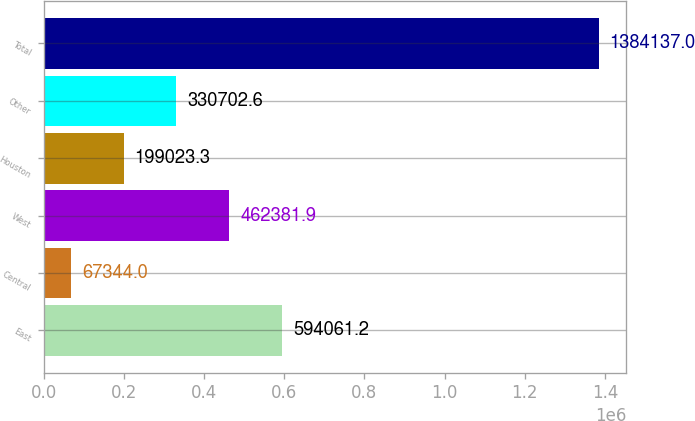Convert chart to OTSL. <chart><loc_0><loc_0><loc_500><loc_500><bar_chart><fcel>East<fcel>Central<fcel>West<fcel>Houston<fcel>Other<fcel>Total<nl><fcel>594061<fcel>67344<fcel>462382<fcel>199023<fcel>330703<fcel>1.38414e+06<nl></chart> 